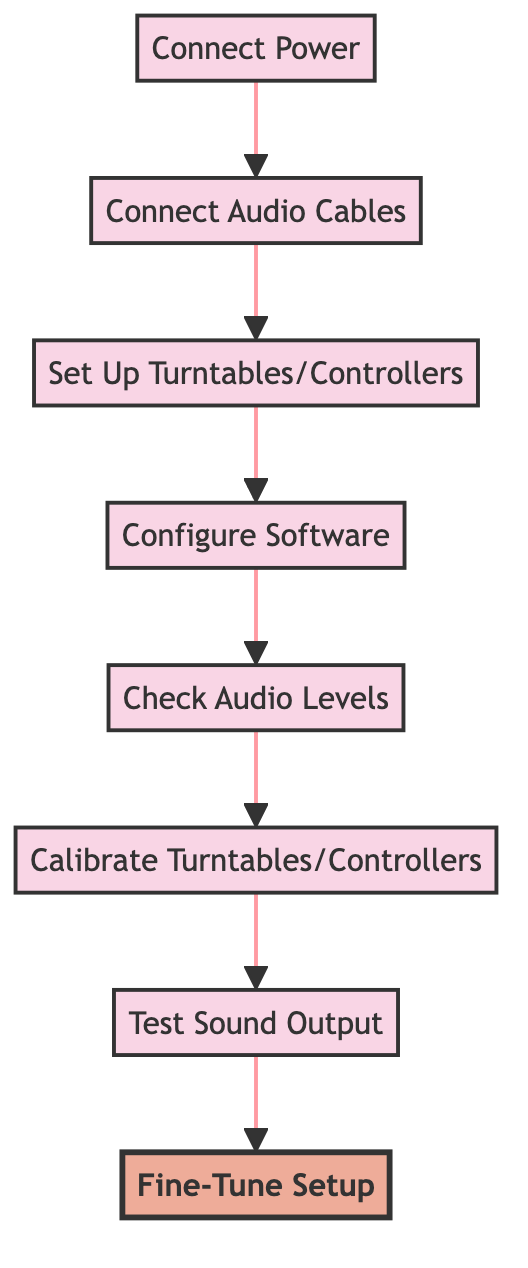What is the first step in the flow chart? The first step in the flow chart is "Connect Power." This can be identified as it is the first node at the bottom of the diagram.
Answer: Connect Power How many steps are there in total in the diagram? The diagram includes eight distinct steps, which can be counted from "Connect Power" to "Fine-Tune Setup."
Answer: 8 What step comes directly after "Set Up Turntables/Controllers"? "Configure Software" is the step that follows "Set Up Turntables/Controllers," as indicated by the flow direction in the diagram.
Answer: Configure Software Which step is the final one in the flow? The last step in the flow is "Fine-Tune Setup," located at the top of the diagram, indicating it comes after all other steps have been completed.
Answer: Fine-Tune Setup What is the main purpose of the "Calibrate Turntables/Controllers" step? The purpose of this step is to ensure accurate tracking by calibrating the turntables or controllers to the DJ software, as described in the node’s information.
Answer: Ensure accurate tracking What are the two steps that come before "Test Sound Output"? The steps prior to "Test Sound Output" are "Calibrate Turntables/Controllers" and "Check Audio Levels," signifying a progression before reaching sound output testing.
Answer: Calibrate Turntables/Controllers, Check Audio Levels What is the significance of the "Fine-Tune Setup" step? The "Fine-Tune Setup" step is highlighted in the diagram, indicating special emphasis on making final adjustments for optimal sound and equipment security.
Answer: Special emphasis on adjustments Which type of cable is used in the "Connect Audio Cables" step? The "Connect Audio Cables" step specifies that RCA or XLR cables should be used, which can be extracted from the description given in the node.
Answer: RCA or XLR cables 